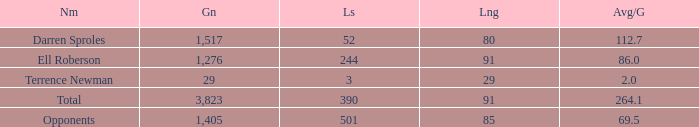When the Gain is 29, and the average per game is 2, and the player lost less than 390 yards, what's the sum of the Long yards? None. 